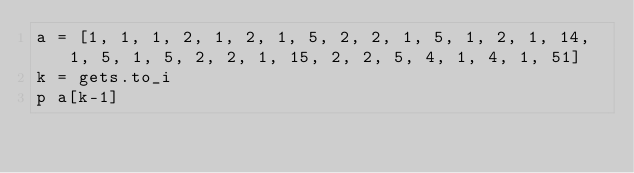<code> <loc_0><loc_0><loc_500><loc_500><_Ruby_>a = [1, 1, 1, 2, 1, 2, 1, 5, 2, 2, 1, 5, 1, 2, 1, 14, 1, 5, 1, 5, 2, 2, 1, 15, 2, 2, 5, 4, 1, 4, 1, 51]
k = gets.to_i
p a[k-1]</code> 